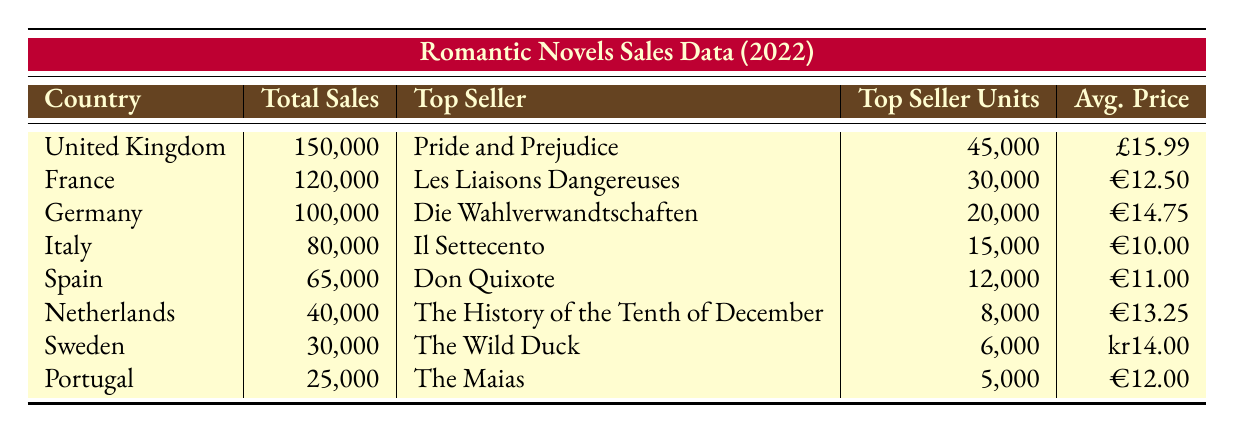What is the total sales for romantic novels in the United Kingdom? The table lists the United Kingdom as having total sales of 150,000 romantic novels for the year 2022.
Answer: 150,000 Which novel was the top seller in France, and how many units were sold? According to the table, the top seller in France was "Les Liaisons Dangereuses" with 30,000 units sold.
Answer: Les Liaisons Dangereuses, 30,000 What was the average price of novels sold in Italy? The table indicates that the average price of novels in Italy was €10.00.
Answer: €10.00 Is the top-selling novel in Germany authored by Johann Wolfgang von Goethe? The table states that the top-selling novel in Germany is "Die Wahlverwandtschaften," written by Johann Wolfgang von Goethe, confirming the statement is true.
Answer: Yes What is the difference in total sales between the United Kingdom and Spain? The total sales for the United Kingdom is 150,000 and for Spain is 65,000. Thus, the difference is 150,000 - 65,000 = 85,000.
Answer: 85,000 What is the average total sales across all countries listed? To find the average total sales: (150,000 + 120,000 + 100,000 + 80,000 + 65,000 + 40,000 + 30,000 + 25,000) = 610,000. Then divide by the number of countries (8), giving an average total sales of 610,000 / 8 = 76,250.
Answer: 76,250 Which country had the lowest total sales, and what were those sales? The table records that Portugal had the lowest total sales at 25,000.
Answer: Portugal, 25,000 Were there any countries that sold more than 100,000 romantic novels? Yes, the table shows that both the United Kingdom and France had total sales exceeding 100,000, confirming that two countries reached this mark.
Answer: Yes List the authors of the top-selling novels in both Italy and Spain. The top-selling novel in Italy is "Il Settecento" by Alessandro Manzoni, and in Spain, it is "Don Quixote" by Miguel de Cervantes. Thus, the authors are Alessandro Manzoni and Miguel de Cervantes.
Answer: Alessandro Manzoni, Miguel de Cervantes 